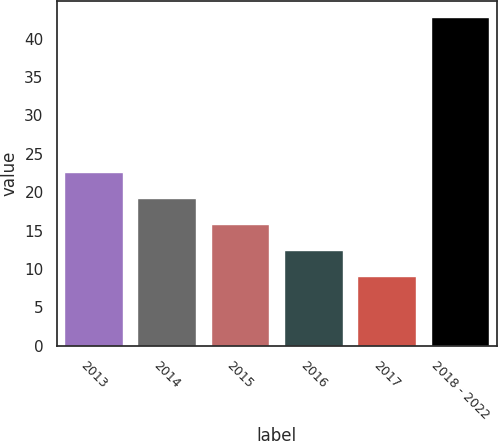<chart> <loc_0><loc_0><loc_500><loc_500><bar_chart><fcel>2013<fcel>2014<fcel>2015<fcel>2016<fcel>2017<fcel>2018 - 2022<nl><fcel>22.58<fcel>19.21<fcel>15.84<fcel>12.47<fcel>9.1<fcel>42.8<nl></chart> 